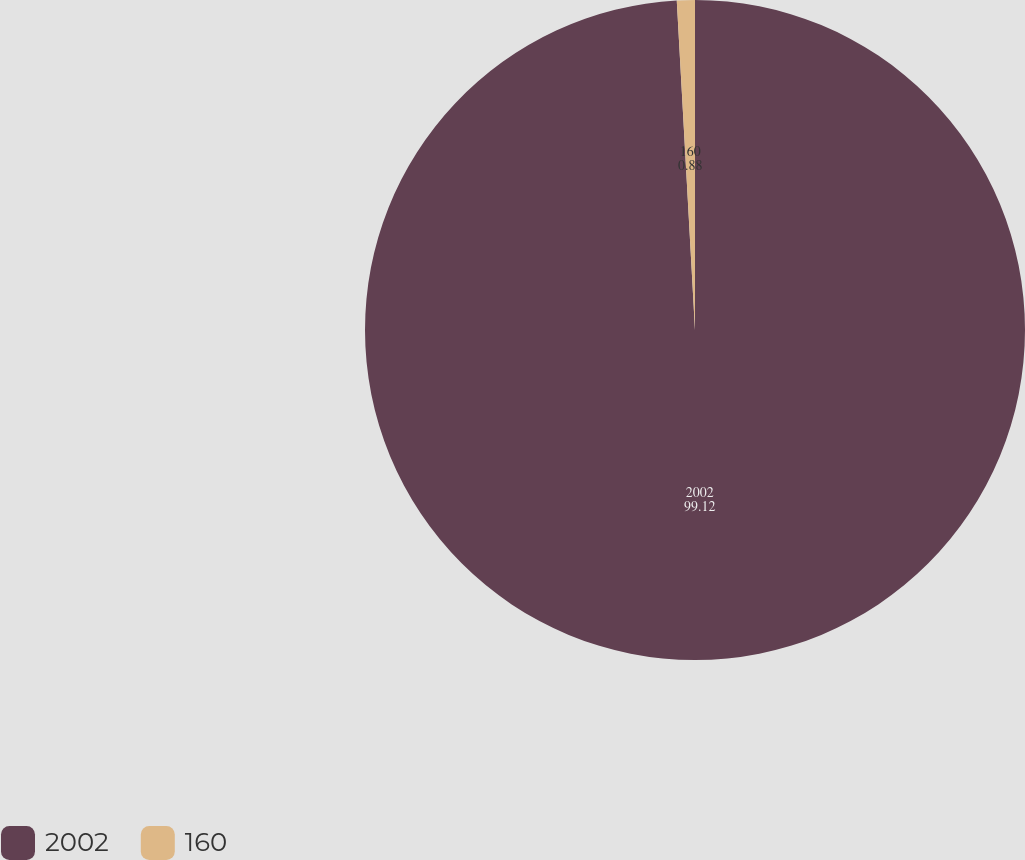Convert chart. <chart><loc_0><loc_0><loc_500><loc_500><pie_chart><fcel>2002<fcel>160<nl><fcel>99.12%<fcel>0.88%<nl></chart> 